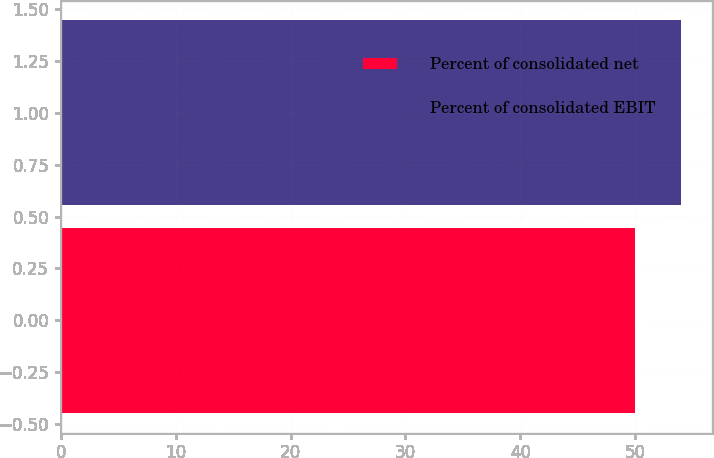<chart> <loc_0><loc_0><loc_500><loc_500><bar_chart><fcel>Percent of consolidated net<fcel>Percent of consolidated EBIT<nl><fcel>50<fcel>54<nl></chart> 